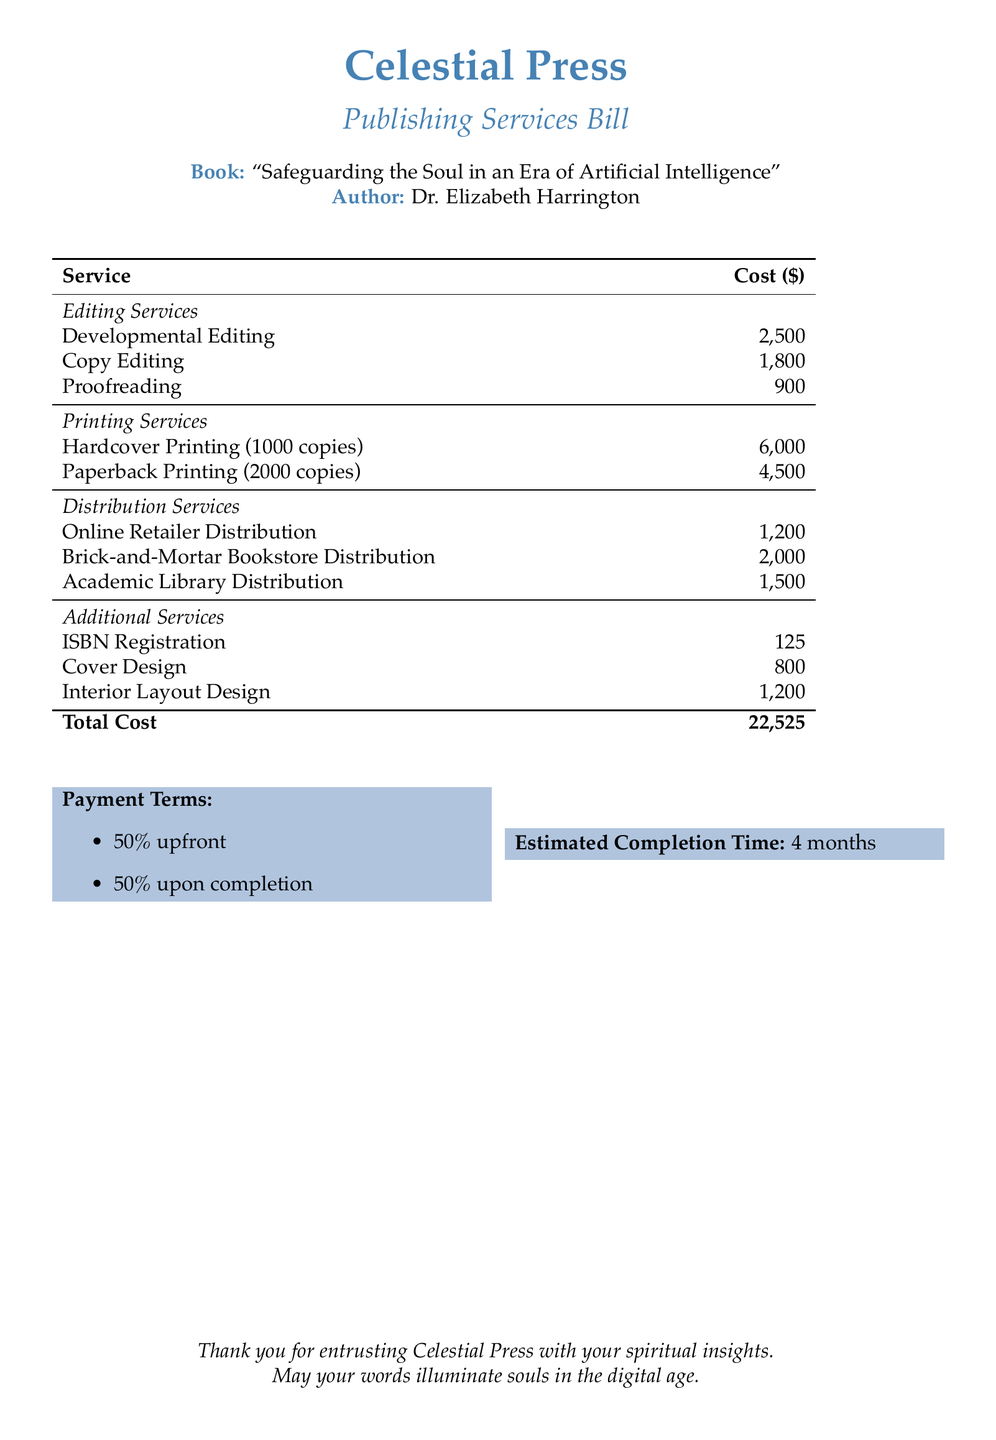What is the author's name? The author's name is mentioned in the document as Dr. Elizabeth Harrington.
Answer: Dr. Elizabeth Harrington What is the total cost for publishing services? The total cost is presented at the bottom of the table in the document as the sum of all service costs.
Answer: 22,525 How much does developmental editing cost? The cost for developmental editing is specified in the editing services section of the document.
Answer: 2,500 What percentage of the total cost is required upfront? The payment terms in the document specify what percentage is required upfront.
Answer: 50% What is the estimated completion time for the services? The estimated completion time is explicitly stated in the document.
Answer: 4 months How much does the hardcover printing for 1000 copies cost? The cost for hardcover printing is listed in the printing services section.
Answer: 6,000 Which service has the highest cost in the document? The highest cost among all services can be deduced from the listed costs in the table.
Answer: Developmental Editing Is there a charge for ISBN registration? The document includes additional services and their respective costs, including ISBN registration.
Answer: 125 What service is provided for brick-and-mortar bookstore distribution? The document lists the services under distribution, identifying the specified service for this type of distribution.
Answer: Brick-and-Mortar Bookstore Distribution 